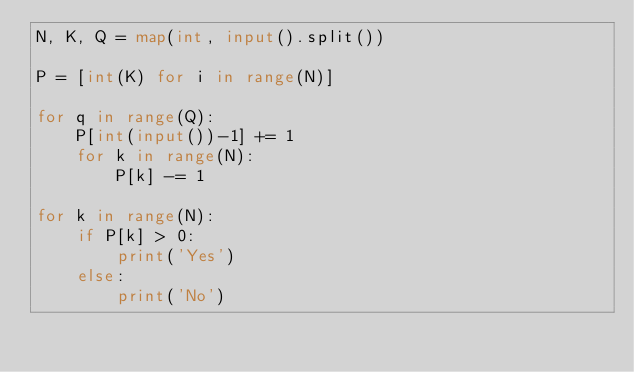<code> <loc_0><loc_0><loc_500><loc_500><_Python_>N, K, Q = map(int, input().split())

P = [int(K) for i in range(N)]

for q in range(Q):
    P[int(input())-1] += 1
    for k in range(N):
        P[k] -= 1

for k in range(N):
    if P[k] > 0:
        print('Yes')
    else:
        print('No')
</code> 